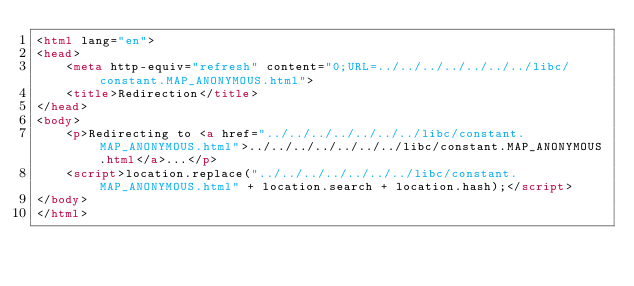<code> <loc_0><loc_0><loc_500><loc_500><_HTML_><html lang="en">
<head>
    <meta http-equiv="refresh" content="0;URL=../../../../../../../libc/constant.MAP_ANONYMOUS.html">
    <title>Redirection</title>
</head>
<body>
    <p>Redirecting to <a href="../../../../../../../libc/constant.MAP_ANONYMOUS.html">../../../../../../../libc/constant.MAP_ANONYMOUS.html</a>...</p>
    <script>location.replace("../../../../../../../libc/constant.MAP_ANONYMOUS.html" + location.search + location.hash);</script>
</body>
</html></code> 